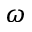Convert formula to latex. <formula><loc_0><loc_0><loc_500><loc_500>\omega</formula> 